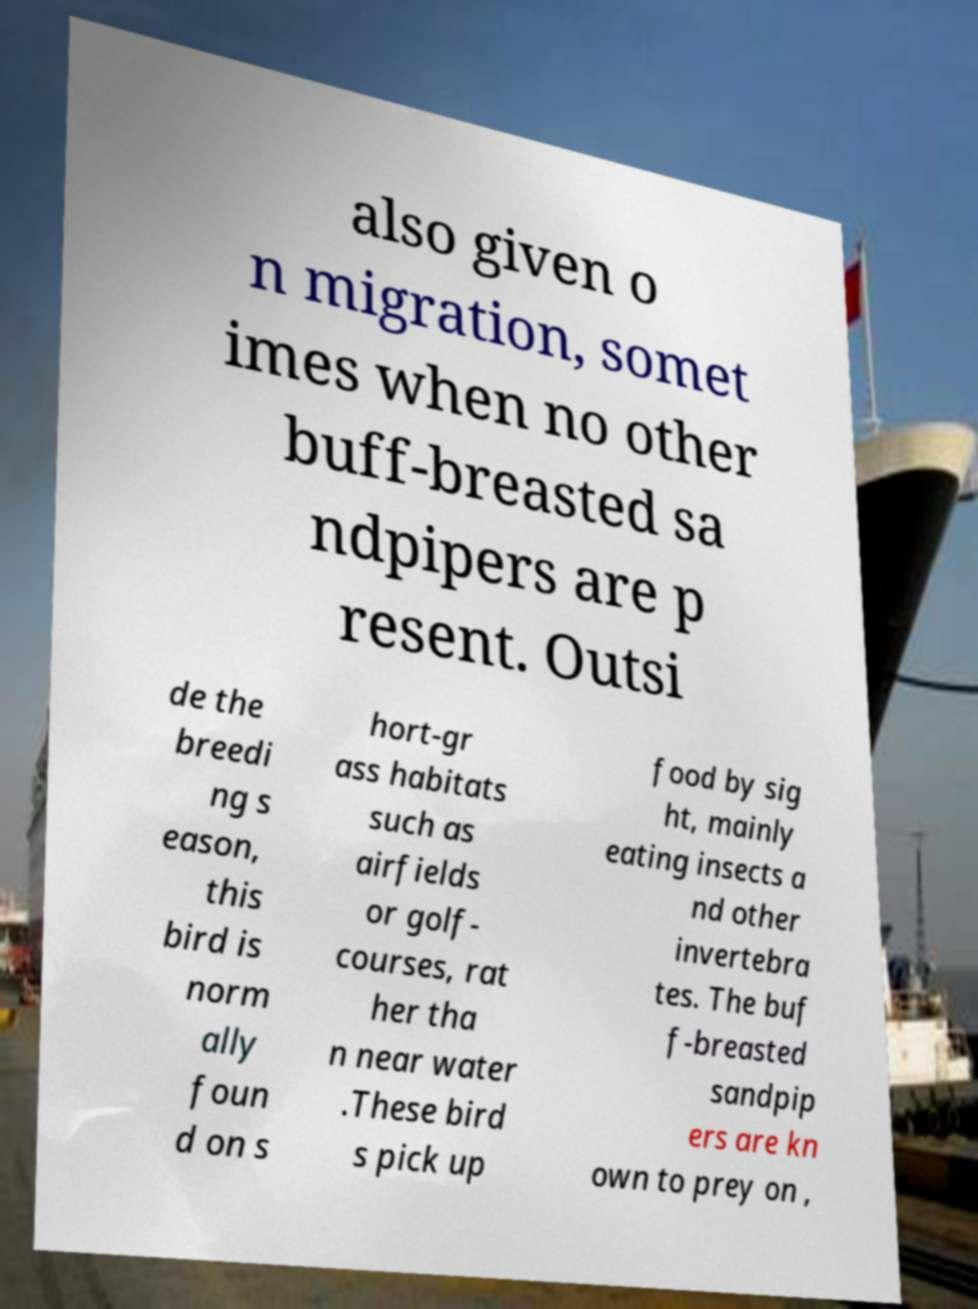Could you assist in decoding the text presented in this image and type it out clearly? also given o n migration, somet imes when no other buff-breasted sa ndpipers are p resent. Outsi de the breedi ng s eason, this bird is norm ally foun d on s hort-gr ass habitats such as airfields or golf- courses, rat her tha n near water .These bird s pick up food by sig ht, mainly eating insects a nd other invertebra tes. The buf f-breasted sandpip ers are kn own to prey on , 